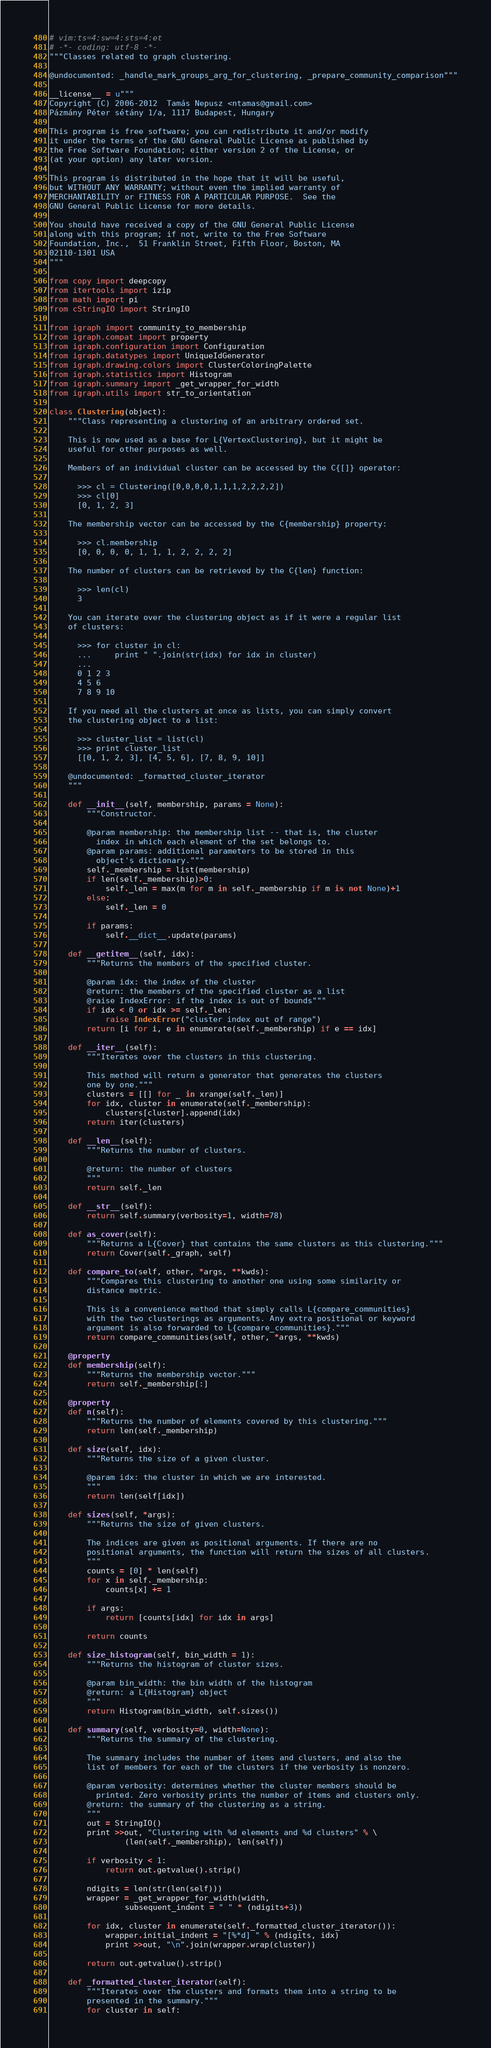<code> <loc_0><loc_0><loc_500><loc_500><_Python_># vim:ts=4:sw=4:sts=4:et
# -*- coding: utf-8 -*-
"""Classes related to graph clustering.

@undocumented: _handle_mark_groups_arg_for_clustering, _prepare_community_comparison"""

__license__ = u"""
Copyright (C) 2006-2012  Tamás Nepusz <ntamas@gmail.com>
Pázmány Péter sétány 1/a, 1117 Budapest, Hungary

This program is free software; you can redistribute it and/or modify
it under the terms of the GNU General Public License as published by
the Free Software Foundation; either version 2 of the License, or
(at your option) any later version.

This program is distributed in the hope that it will be useful,
but WITHOUT ANY WARRANTY; without even the implied warranty of
MERCHANTABILITY or FITNESS FOR A PARTICULAR PURPOSE.  See the
GNU General Public License for more details.

You should have received a copy of the GNU General Public License
along with this program; if not, write to the Free Software
Foundation, Inc.,  51 Franklin Street, Fifth Floor, Boston, MA
02110-1301 USA
"""

from copy import deepcopy
from itertools import izip
from math import pi
from cStringIO import StringIO

from igraph import community_to_membership
from igraph.compat import property
from igraph.configuration import Configuration
from igraph.datatypes import UniqueIdGenerator
from igraph.drawing.colors import ClusterColoringPalette
from igraph.statistics import Histogram
from igraph.summary import _get_wrapper_for_width
from igraph.utils import str_to_orientation

class Clustering(object):
    """Class representing a clustering of an arbitrary ordered set.

    This is now used as a base for L{VertexClustering}, but it might be
    useful for other purposes as well.

    Members of an individual cluster can be accessed by the C{[]} operator:

      >>> cl = Clustering([0,0,0,0,1,1,1,2,2,2,2])
      >>> cl[0]
      [0, 1, 2, 3]

    The membership vector can be accessed by the C{membership} property:

      >>> cl.membership
      [0, 0, 0, 0, 1, 1, 1, 2, 2, 2, 2]

    The number of clusters can be retrieved by the C{len} function:

      >>> len(cl)
      3

    You can iterate over the clustering object as if it were a regular list
    of clusters:

      >>> for cluster in cl:
      ...     print " ".join(str(idx) for idx in cluster)
      ...
      0 1 2 3
      4 5 6
      7 8 9 10

    If you need all the clusters at once as lists, you can simply convert
    the clustering object to a list:

      >>> cluster_list = list(cl)
      >>> print cluster_list
      [[0, 1, 2, 3], [4, 5, 6], [7, 8, 9, 10]]

    @undocumented: _formatted_cluster_iterator
    """

    def __init__(self, membership, params = None):
        """Constructor.

        @param membership: the membership list -- that is, the cluster
          index in which each element of the set belongs to.
        @param params: additional parameters to be stored in this
          object's dictionary."""
        self._membership = list(membership)
        if len(self._membership)>0:
            self._len = max(m for m in self._membership if m is not None)+1
        else:
            self._len = 0

        if params:
            self.__dict__.update(params)

    def __getitem__(self, idx):
        """Returns the members of the specified cluster.

        @param idx: the index of the cluster
        @return: the members of the specified cluster as a list
        @raise IndexError: if the index is out of bounds"""
        if idx < 0 or idx >= self._len:
            raise IndexError("cluster index out of range")
        return [i for i, e in enumerate(self._membership) if e == idx]

    def __iter__(self):
        """Iterates over the clusters in this clustering.

        This method will return a generator that generates the clusters
        one by one."""
        clusters = [[] for _ in xrange(self._len)]
        for idx, cluster in enumerate(self._membership):
            clusters[cluster].append(idx)
        return iter(clusters)

    def __len__(self):
        """Returns the number of clusters.

        @return: the number of clusters
        """
        return self._len

    def __str__(self):
        return self.summary(verbosity=1, width=78)

    def as_cover(self):
        """Returns a L{Cover} that contains the same clusters as this clustering."""
        return Cover(self._graph, self)

    def compare_to(self, other, *args, **kwds):
        """Compares this clustering to another one using some similarity or
        distance metric.

        This is a convenience method that simply calls L{compare_communities}
        with the two clusterings as arguments. Any extra positional or keyword
        argument is also forwarded to L{compare_communities}."""
        return compare_communities(self, other, *args, **kwds)

    @property
    def membership(self):
        """Returns the membership vector."""
        return self._membership[:]

    @property
    def n(self):
        """Returns the number of elements covered by this clustering."""
        return len(self._membership)

    def size(self, idx):
        """Returns the size of a given cluster.

        @param idx: the cluster in which we are interested.
        """
        return len(self[idx])

    def sizes(self, *args):
        """Returns the size of given clusters.

        The indices are given as positional arguments. If there are no
        positional arguments, the function will return the sizes of all clusters.
        """
        counts = [0] * len(self)
        for x in self._membership:
            counts[x] += 1

        if args:
            return [counts[idx] for idx in args]

        return counts

    def size_histogram(self, bin_width = 1):
        """Returns the histogram of cluster sizes.

        @param bin_width: the bin width of the histogram
        @return: a L{Histogram} object
        """
        return Histogram(bin_width, self.sizes())

    def summary(self, verbosity=0, width=None):
        """Returns the summary of the clustering.

        The summary includes the number of items and clusters, and also the
        list of members for each of the clusters if the verbosity is nonzero.

        @param verbosity: determines whether the cluster members should be
          printed. Zero verbosity prints the number of items and clusters only.
        @return: the summary of the clustering as a string.
        """
        out = StringIO()
        print >>out, "Clustering with %d elements and %d clusters" % \
                (len(self._membership), len(self))

        if verbosity < 1:
            return out.getvalue().strip()

        ndigits = len(str(len(self)))
        wrapper = _get_wrapper_for_width(width,
                subsequent_indent = " " * (ndigits+3))

        for idx, cluster in enumerate(self._formatted_cluster_iterator()):
            wrapper.initial_indent = "[%*d] " % (ndigits, idx)
            print >>out, "\n".join(wrapper.wrap(cluster))

        return out.getvalue().strip()

    def _formatted_cluster_iterator(self):
        """Iterates over the clusters and formats them into a string to be
        presented in the summary."""
        for cluster in self:</code> 